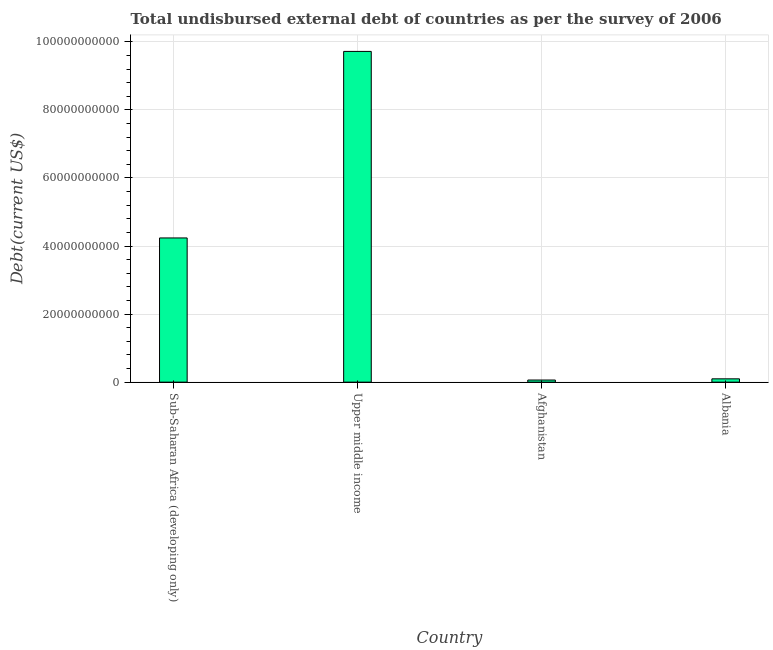Does the graph contain any zero values?
Provide a short and direct response. No. What is the title of the graph?
Your answer should be very brief. Total undisbursed external debt of countries as per the survey of 2006. What is the label or title of the Y-axis?
Your answer should be compact. Debt(current US$). What is the total debt in Upper middle income?
Make the answer very short. 9.72e+1. Across all countries, what is the maximum total debt?
Ensure brevity in your answer.  9.72e+1. Across all countries, what is the minimum total debt?
Your answer should be compact. 6.26e+08. In which country was the total debt maximum?
Ensure brevity in your answer.  Upper middle income. In which country was the total debt minimum?
Your answer should be very brief. Afghanistan. What is the sum of the total debt?
Provide a succinct answer. 1.41e+11. What is the difference between the total debt in Afghanistan and Upper middle income?
Make the answer very short. -9.66e+1. What is the average total debt per country?
Keep it short and to the point. 3.53e+1. What is the median total debt?
Your answer should be compact. 2.17e+1. In how many countries, is the total debt greater than 76000000000 US$?
Your response must be concise. 1. What is the ratio of the total debt in Afghanistan to that in Sub-Saharan Africa (developing only)?
Your answer should be very brief. 0.01. Is the total debt in Afghanistan less than that in Upper middle income?
Offer a terse response. Yes. What is the difference between the highest and the second highest total debt?
Keep it short and to the point. 5.48e+1. Is the sum of the total debt in Afghanistan and Sub-Saharan Africa (developing only) greater than the maximum total debt across all countries?
Your answer should be very brief. No. What is the difference between the highest and the lowest total debt?
Your answer should be very brief. 9.66e+1. How many bars are there?
Give a very brief answer. 4. What is the difference between two consecutive major ticks on the Y-axis?
Make the answer very short. 2.00e+1. Are the values on the major ticks of Y-axis written in scientific E-notation?
Your response must be concise. No. What is the Debt(current US$) in Sub-Saharan Africa (developing only)?
Ensure brevity in your answer.  4.24e+1. What is the Debt(current US$) in Upper middle income?
Make the answer very short. 9.72e+1. What is the Debt(current US$) in Afghanistan?
Keep it short and to the point. 6.26e+08. What is the Debt(current US$) of Albania?
Give a very brief answer. 9.75e+08. What is the difference between the Debt(current US$) in Sub-Saharan Africa (developing only) and Upper middle income?
Ensure brevity in your answer.  -5.48e+1. What is the difference between the Debt(current US$) in Sub-Saharan Africa (developing only) and Afghanistan?
Offer a terse response. 4.18e+1. What is the difference between the Debt(current US$) in Sub-Saharan Africa (developing only) and Albania?
Keep it short and to the point. 4.14e+1. What is the difference between the Debt(current US$) in Upper middle income and Afghanistan?
Give a very brief answer. 9.66e+1. What is the difference between the Debt(current US$) in Upper middle income and Albania?
Offer a terse response. 9.62e+1. What is the difference between the Debt(current US$) in Afghanistan and Albania?
Provide a succinct answer. -3.49e+08. What is the ratio of the Debt(current US$) in Sub-Saharan Africa (developing only) to that in Upper middle income?
Your response must be concise. 0.44. What is the ratio of the Debt(current US$) in Sub-Saharan Africa (developing only) to that in Afghanistan?
Keep it short and to the point. 67.68. What is the ratio of the Debt(current US$) in Sub-Saharan Africa (developing only) to that in Albania?
Provide a short and direct response. 43.47. What is the ratio of the Debt(current US$) in Upper middle income to that in Afghanistan?
Give a very brief answer. 155.24. What is the ratio of the Debt(current US$) in Upper middle income to that in Albania?
Keep it short and to the point. 99.7. What is the ratio of the Debt(current US$) in Afghanistan to that in Albania?
Your answer should be compact. 0.64. 